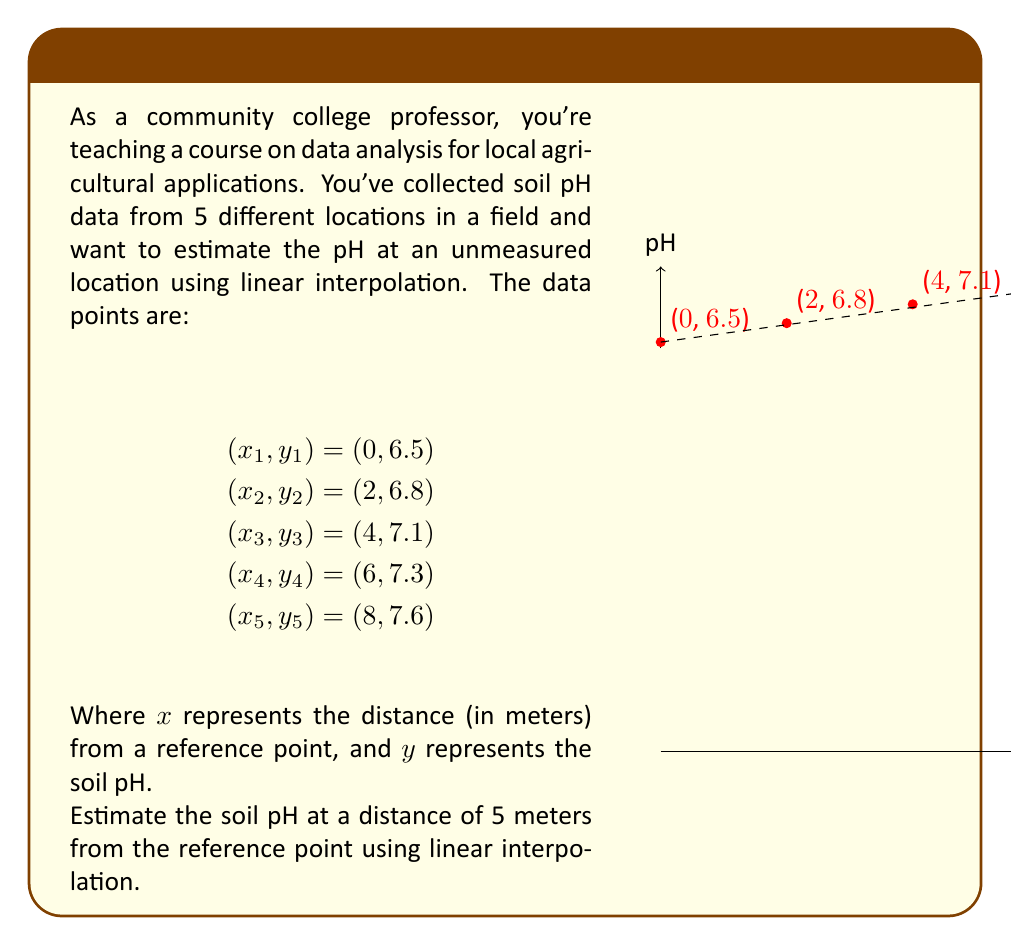Can you solve this math problem? To estimate the soil pH at 5 meters using linear interpolation, we need to:

1) Identify the two known data points that bracket our desired x-value (5 meters).
   The bracketing points are $(x_3, y_3) = (4, 7.1)$ and $(x_4, y_4) = (6, 7.3)$.

2) Use the linear interpolation formula:

   $$y = y_3 + \frac{y_4 - y_3}{x_4 - x_3}(x - x_3)$$

   where $x = 5$ (our desired point of interpolation)

3) Substitute the values:

   $$y = 7.1 + \frac{7.3 - 7.1}{6 - 4}(5 - 4)$$

4) Simplify:
   $$y = 7.1 + \frac{0.2}{2}(1)$$
   $$y = 7.1 + 0.1$$
   $$y = 7.2$$

Therefore, the estimated soil pH at 5 meters from the reference point is 7.2.
Answer: 7.2 